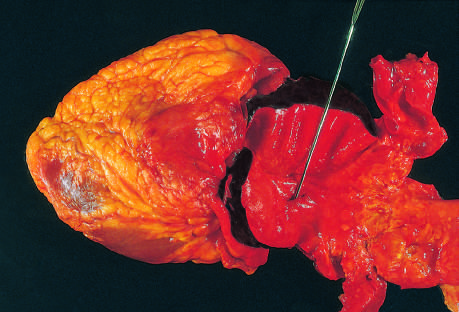does the distal edge of the intramural hematoma lie at the edge of a large area of atherosclerosis, which arrested the propagation of the dissection?
Answer the question using a single word or phrase. Yes 